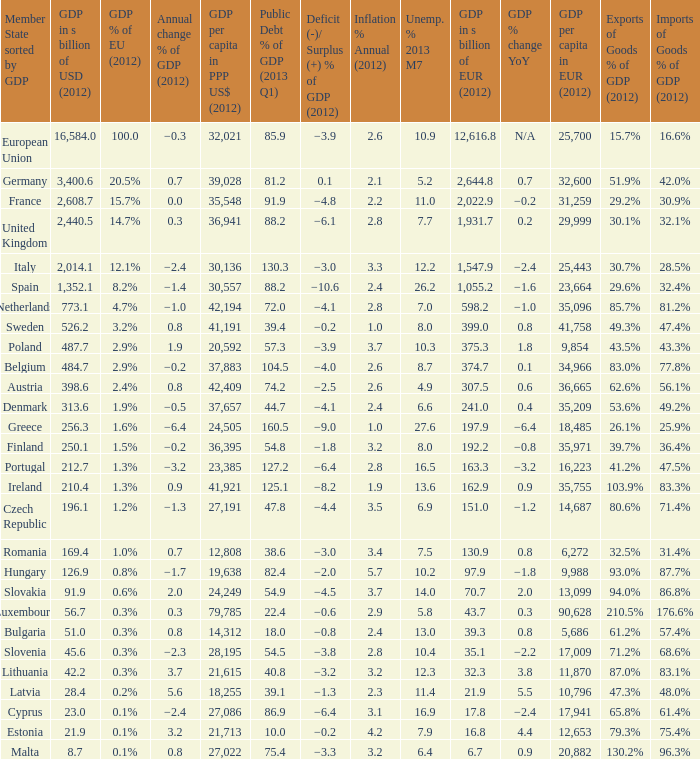What is the GDP % of EU in 2012 of the country with a GDP in billions of USD in 2012 of 256.3? 1.6%. 